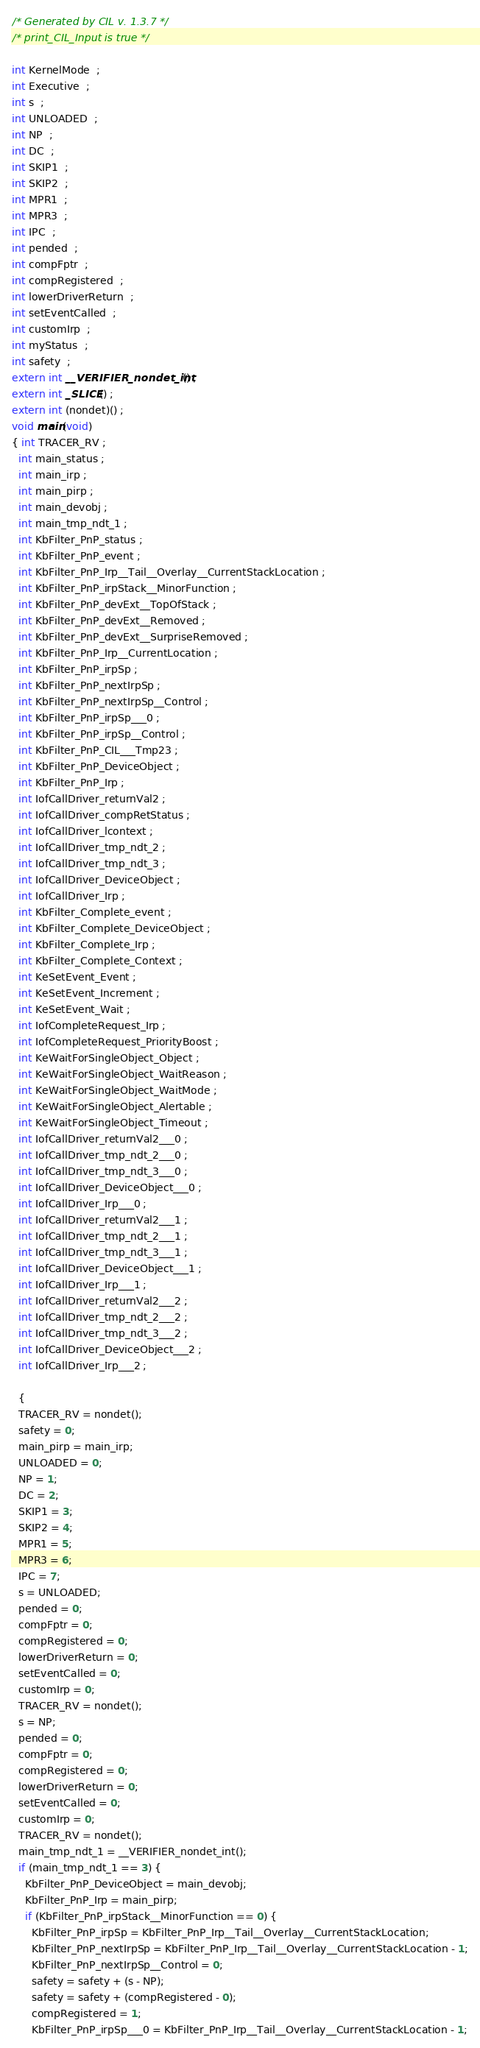Convert code to text. <code><loc_0><loc_0><loc_500><loc_500><_C_>/* Generated by CIL v. 1.3.7 */
/* print_CIL_Input is true */

int KernelMode  ;
int Executive  ;
int s  ;
int UNLOADED  ;
int NP  ;
int DC  ;
int SKIP1  ;
int SKIP2  ;
int MPR1  ;
int MPR3  ;
int IPC  ;
int pended  ;
int compFptr  ;
int compRegistered  ;
int lowerDriverReturn  ;
int setEventCalled  ;
int customIrp  ;
int myStatus  ;
int safety  ;
extern int __VERIFIER_nondet_int() ;
extern int _SLICE() ;
extern int (nondet)() ;
void main(void) 
{ int TRACER_RV ;
  int main_status ;
  int main_irp ;
  int main_pirp ;
  int main_devobj ;
  int main_tmp_ndt_1 ;
  int KbFilter_PnP_status ;
  int KbFilter_PnP_event ;
  int KbFilter_PnP_Irp__Tail__Overlay__CurrentStackLocation ;
  int KbFilter_PnP_irpStack__MinorFunction ;
  int KbFilter_PnP_devExt__TopOfStack ;
  int KbFilter_PnP_devExt__Removed ;
  int KbFilter_PnP_devExt__SurpriseRemoved ;
  int KbFilter_PnP_Irp__CurrentLocation ;
  int KbFilter_PnP_irpSp ;
  int KbFilter_PnP_nextIrpSp ;
  int KbFilter_PnP_nextIrpSp__Control ;
  int KbFilter_PnP_irpSp___0 ;
  int KbFilter_PnP_irpSp__Control ;
  int KbFilter_PnP_CIL___Tmp23 ;
  int KbFilter_PnP_DeviceObject ;
  int KbFilter_PnP_Irp ;
  int IofCallDriver_returnVal2 ;
  int IofCallDriver_compRetStatus ;
  int IofCallDriver_lcontext ;
  int IofCallDriver_tmp_ndt_2 ;
  int IofCallDriver_tmp_ndt_3 ;
  int IofCallDriver_DeviceObject ;
  int IofCallDriver_Irp ;
  int KbFilter_Complete_event ;
  int KbFilter_Complete_DeviceObject ;
  int KbFilter_Complete_Irp ;
  int KbFilter_Complete_Context ;
  int KeSetEvent_Event ;
  int KeSetEvent_Increment ;
  int KeSetEvent_Wait ;
  int IofCompleteRequest_Irp ;
  int IofCompleteRequest_PriorityBoost ;
  int KeWaitForSingleObject_Object ;
  int KeWaitForSingleObject_WaitReason ;
  int KeWaitForSingleObject_WaitMode ;
  int KeWaitForSingleObject_Alertable ;
  int KeWaitForSingleObject_Timeout ;
  int IofCallDriver_returnVal2___0 ;
  int IofCallDriver_tmp_ndt_2___0 ;
  int IofCallDriver_tmp_ndt_3___0 ;
  int IofCallDriver_DeviceObject___0 ;
  int IofCallDriver_Irp___0 ;
  int IofCallDriver_returnVal2___1 ;
  int IofCallDriver_tmp_ndt_2___1 ;
  int IofCallDriver_tmp_ndt_3___1 ;
  int IofCallDriver_DeviceObject___1 ;
  int IofCallDriver_Irp___1 ;
  int IofCallDriver_returnVal2___2 ;
  int IofCallDriver_tmp_ndt_2___2 ;
  int IofCallDriver_tmp_ndt_3___2 ;
  int IofCallDriver_DeviceObject___2 ;
  int IofCallDriver_Irp___2 ;

  {
  TRACER_RV = nondet();
  safety = 0;
  main_pirp = main_irp;
  UNLOADED = 0;
  NP = 1;
  DC = 2;
  SKIP1 = 3;
  SKIP2 = 4;
  MPR1 = 5;
  MPR3 = 6;
  IPC = 7;
  s = UNLOADED;
  pended = 0;
  compFptr = 0;
  compRegistered = 0;
  lowerDriverReturn = 0;
  setEventCalled = 0;
  customIrp = 0;
  TRACER_RV = nondet();
  s = NP;
  pended = 0;
  compFptr = 0;
  compRegistered = 0;
  lowerDriverReturn = 0;
  setEventCalled = 0;
  customIrp = 0;
  TRACER_RV = nondet();
  main_tmp_ndt_1 = __VERIFIER_nondet_int();
  if (main_tmp_ndt_1 == 3) {
    KbFilter_PnP_DeviceObject = main_devobj;
    KbFilter_PnP_Irp = main_pirp;
    if (KbFilter_PnP_irpStack__MinorFunction == 0) {
      KbFilter_PnP_irpSp = KbFilter_PnP_Irp__Tail__Overlay__CurrentStackLocation;
      KbFilter_PnP_nextIrpSp = KbFilter_PnP_Irp__Tail__Overlay__CurrentStackLocation - 1;
      KbFilter_PnP_nextIrpSp__Control = 0;
      safety = safety + (s - NP);
      safety = safety + (compRegistered - 0);
      compRegistered = 1;
      KbFilter_PnP_irpSp___0 = KbFilter_PnP_Irp__Tail__Overlay__CurrentStackLocation - 1;</code> 